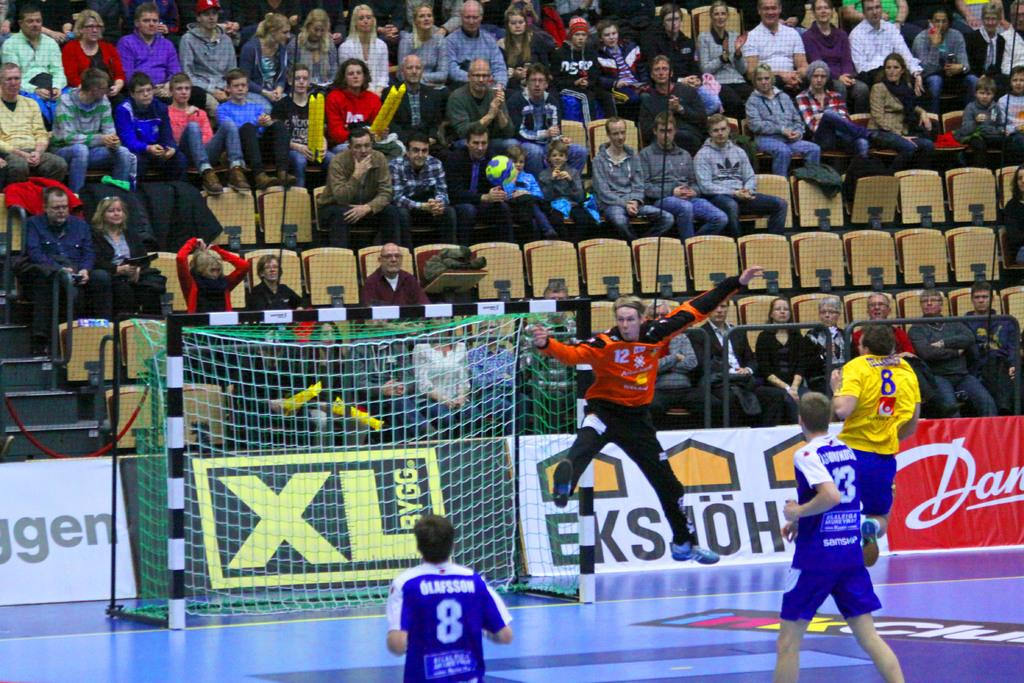<image>
Render a clear and concise summary of the photo. A big black sign behind the goal has XL in yellow. 